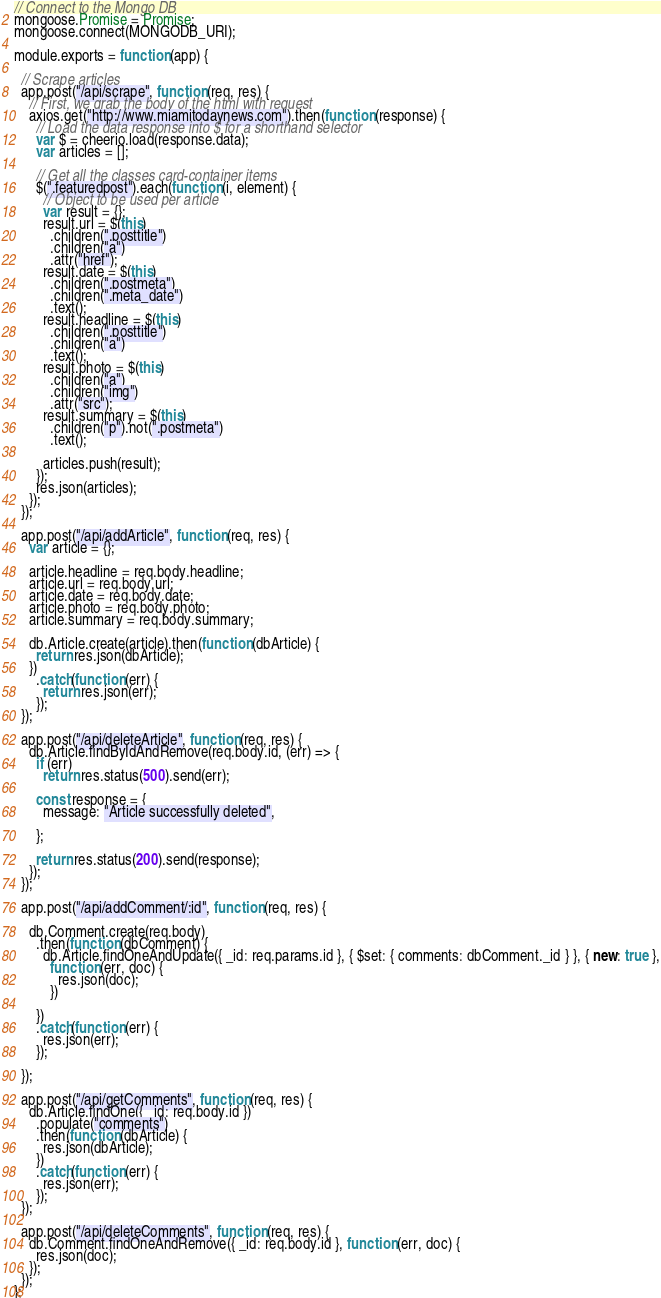Convert code to text. <code><loc_0><loc_0><loc_500><loc_500><_JavaScript_>// Connect to the Mongo DB
mongoose.Promise = Promise;
mongoose.connect(MONGODB_URI);

module.exports = function (app) {

  // Scrape articles
  app.post("/api/scrape", function (req, res) {
    // First, we grab the body of the html with request
    axios.get("http://www.miamitodaynews.com").then(function (response) {
      // Load the data response into $ for a shorthand selector
      var $ = cheerio.load(response.data);
      var articles = [];

      // Get all the classes card-container items
      $(".featuredpost").each(function (i, element) {
        // Object to be used per article
        var result = {};
        result.url = $(this)
          .children(".posttitle")
          .children("a")
          .attr("href");
        result.date = $(this)
          .children(".postmeta")
          .children(".meta_date")
          .text();
        result.headline = $(this)
          .children(".posttitle")
          .children("a")
          .text();
        result.photo = $(this)
          .children("a")
          .children("img")
          .attr("src");
        result.summary = $(this)
          .children("p").not(".postmeta")
          .text();

        articles.push(result);
      });
      res.json(articles);
    });
  });

  app.post("/api/addArticle", function (req, res) {
    var article = {};

    article.headline = req.body.headline;
    article.url = req.body.url;
    article.date = req.body.date;
    article.photo = req.body.photo;
    article.summary = req.body.summary;

    db.Article.create(article).then(function (dbArticle) {
      return res.json(dbArticle);
    })
      .catch(function (err) {
        return res.json(err);
      });
  });

  app.post("/api/deleteArticle", function (req, res) {
    db.Article.findByIdAndRemove(req.body.id, (err) => {
      if (err)
        return res.status(500).send(err);

      const response = {
        message: "Article successfully deleted",

      };

      return res.status(200).send(response);
    });
  });

  app.post("/api/addComment/:id", function (req, res) {

    db.Comment.create(req.body)
      .then(function (dbComment) {
        db.Article.findOneAndUpdate({ _id: req.params.id }, { $set: { comments: dbComment._id } }, { new: true },
          function (err, doc) {
            res.json(doc);
          })

      })
      .catch(function (err) {
        res.json(err);
      });

  });

  app.post("/api/getComments", function (req, res) {
    db.Article.findOne({ _id: req.body.id })
      .populate("comments")
      .then(function (dbArticle) {
        res.json(dbArticle);
      })
      .catch(function (err) {
        res.json(err);
      });
  });

  app.post("/api/deleteComments", function (req, res) {
    db.Comment.findOneAndRemove({ _id: req.body.id }, function (err, doc) {
      res.json(doc);
    });
  });
};



</code> 